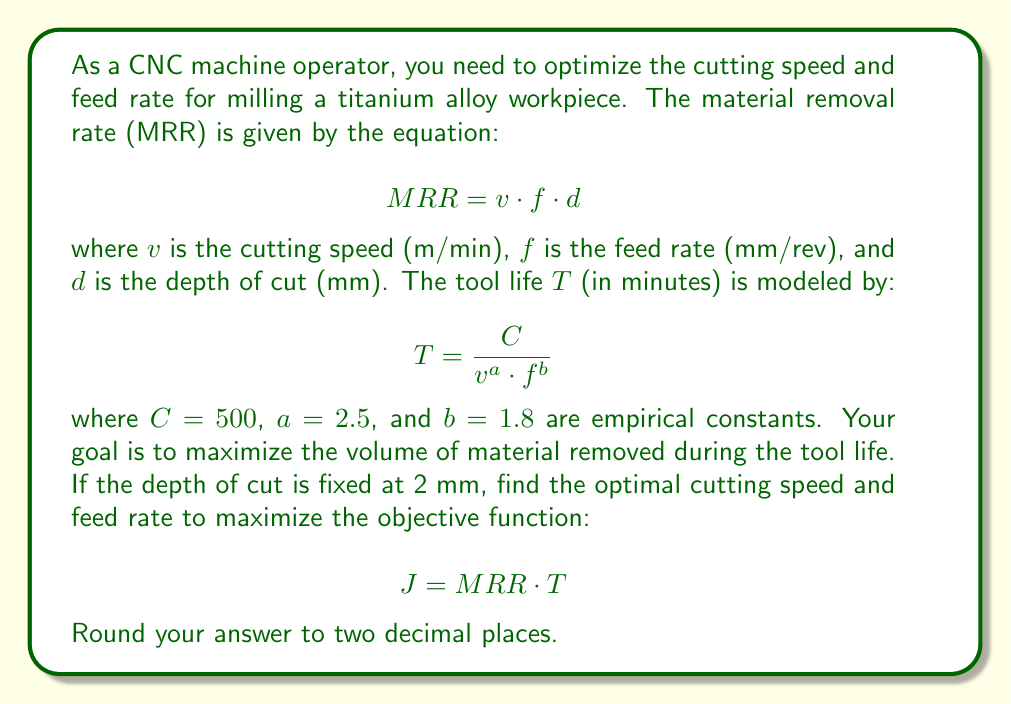Show me your answer to this math problem. To solve this optimization problem, we'll follow these steps:

1) Express the objective function $J$ in terms of $v$ and $f$:

   $$ J = MRR \cdot T = (v \cdot f \cdot d) \cdot \frac{C}{v^a \cdot f^b} $$

2) Substitute the known values:

   $$ J = (v \cdot f \cdot 2) \cdot \frac{500}{v^{2.5} \cdot f^{1.8}} $$

3) Simplify:

   $$ J = 1000 \cdot v^{-1.5} \cdot f^{-0.8} $$

4) To find the maximum, we need to find the partial derivatives with respect to $v$ and $f$ and set them to zero:

   $$ \frac{\partial J}{\partial v} = -1500 \cdot v^{-2.5} \cdot f^{-0.8} = 0 $$
   $$ \frac{\partial J}{\partial f} = -800 \cdot v^{-1.5} \cdot f^{-1.8} = 0 $$

5) These equations are always zero only when $v$ and $f$ approach infinity, which is not practical. Instead, we need to find the relationship between $v$ and $f$ at the optimum:

   $$ \frac{\partial J}{\partial v} = \frac{\partial J}{\partial f} $$

6) Simplify:

   $$ -1500 \cdot v^{-2.5} \cdot f^{-0.8} = -800 \cdot v^{-1.5} \cdot f^{-1.8} $$

7) Solve for $f$ in terms of $v$:

   $$ f = \left(\frac{15}{8}\right)^{1/1} \cdot v^{1/1} = 1.875v $$

8) Substitute this back into the original objective function:

   $$ J = 1000 \cdot v^{-1.5} \cdot (1.875v)^{-0.8} $$

9) Simplify:

   $$ J = 1000 \cdot v^{-1.5} \cdot 1.875^{-0.8} \cdot v^{-0.8} = 568.92 \cdot v^{-2.3} $$

10) Differentiate with respect to $v$ and set to zero:

    $$ \frac{dJ}{dv} = -1308.52 \cdot v^{-3.3} = 0 $$

11) This equation is only satisfied when $v$ approaches infinity. In practice, we need to consider constraints such as maximum allowable cutting speed and feed rate. Let's assume the maximum cutting speed is 100 m/min and the maximum feed rate is 0.5 mm/rev.

12) Using the relationship $f = 1.875v$, we can find the maximum allowable $v$:

    $$ 0.5 = 1.875v $$
    $$ v = 0.2667 $$

13) This is less than 100 m/min, so it's our limiting factor. The optimal cutting speed is 26.67 m/min, and the optimal feed rate is 0.5 mm/rev.
Answer: Optimal cutting speed: 26.67 m/min
Optimal feed rate: 0.50 mm/rev 